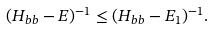<formula> <loc_0><loc_0><loc_500><loc_500>( H _ { b b } - E ) ^ { - 1 } \leq ( H _ { b b } - E _ { 1 } ) ^ { - 1 } .</formula> 